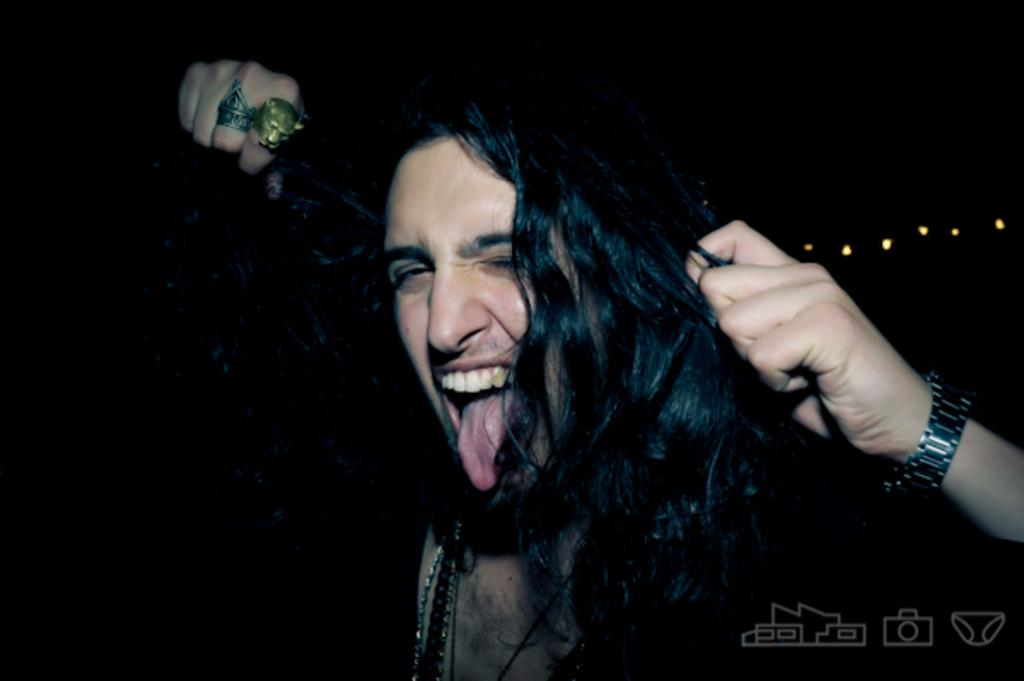What is the main subject of the image? There is a person in the image. What is the person doing with their tongue? The person has their tongue outside. How is the person holding their hair? The person is holding their hair with their left hand. Are there any accessories visible on the person's hands? Yes, there are two rings on the person's right hand. What type of horses can be seen in the image? There are no horses present in the image; it features a person with their tongue outside and holding their hair. What does the person's tongue smell like in the image? The image does not provide any information about the smell of the person's tongue. 